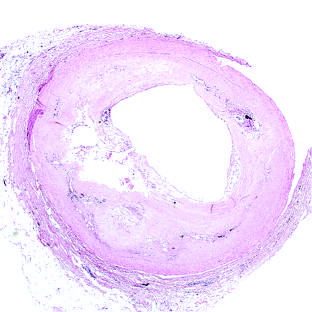what is plaque rupture without?
Answer the question using a single word or phrase. Superimposed thrombus 